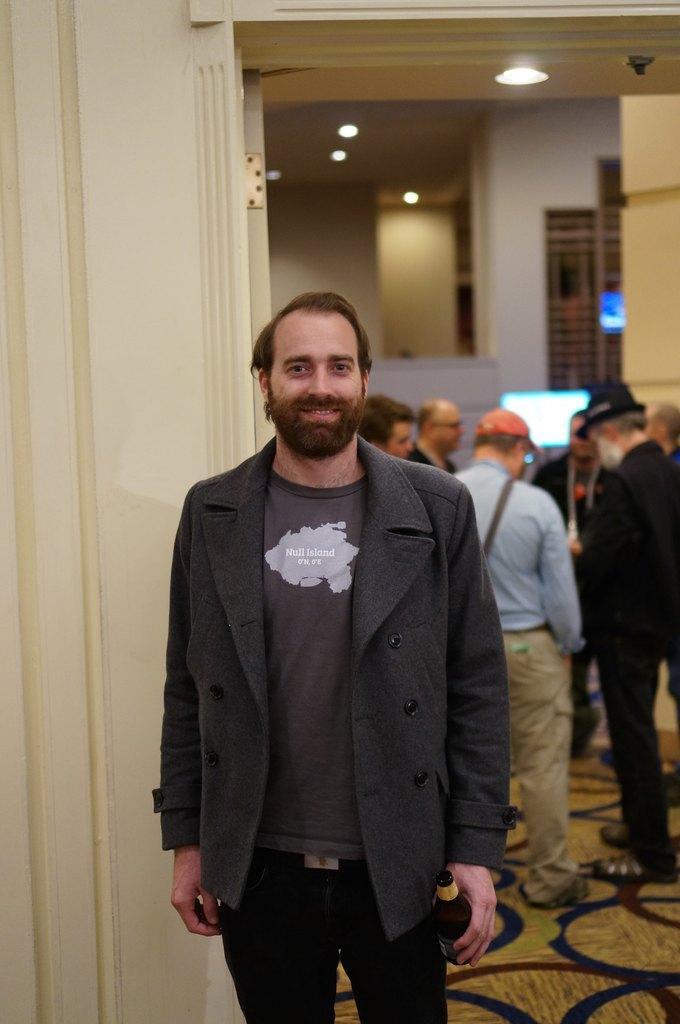Describe this image in one or two sentences. This image is taken indoors. At the bottom of the image there is a floor. In the middle of the image a man is standing on the floor and he is holding a bottle in his hands. In the background there are a few walls with doors. At the top of the image there is a ceiling with lights. In the background there is a monitor on the table and a few people are standing on the floor. 